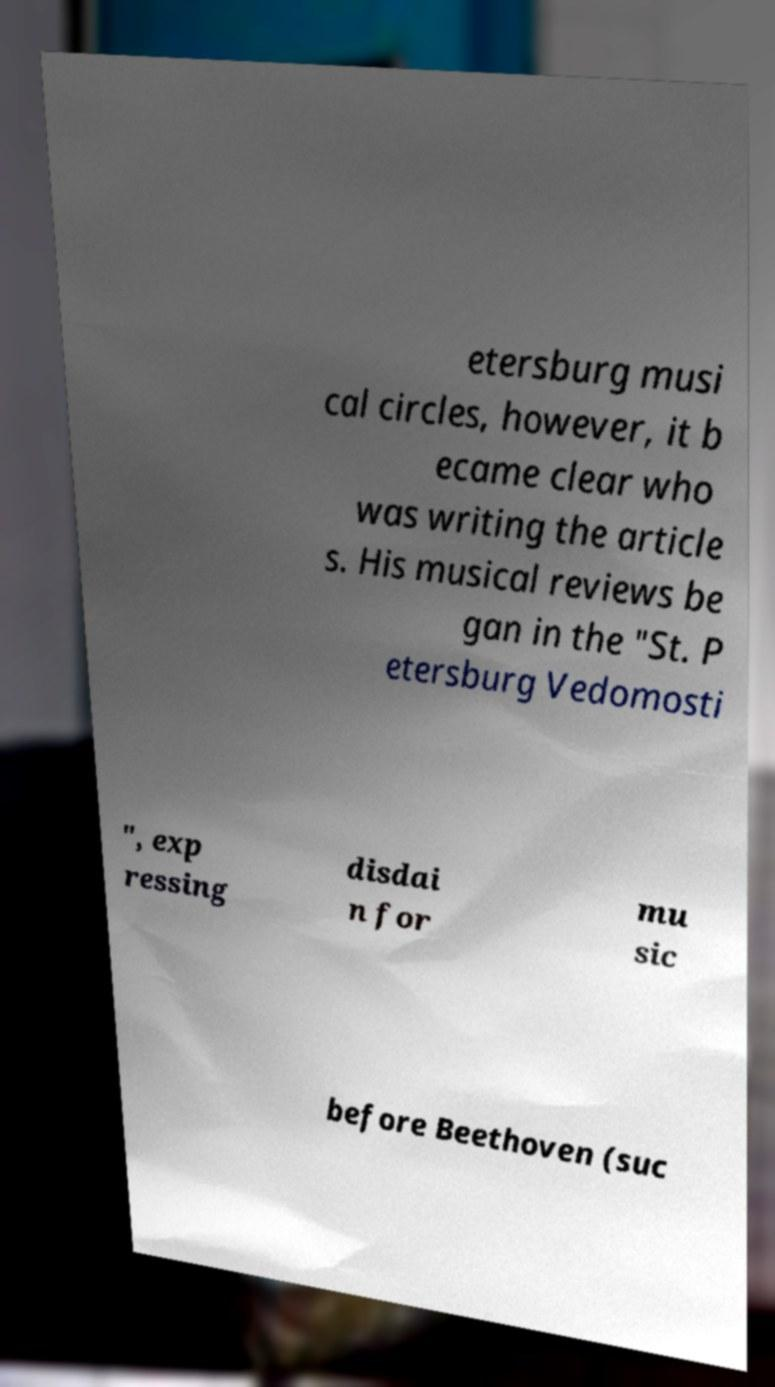Could you assist in decoding the text presented in this image and type it out clearly? etersburg musi cal circles, however, it b ecame clear who was writing the article s. His musical reviews be gan in the "St. P etersburg Vedomosti ", exp ressing disdai n for mu sic before Beethoven (suc 